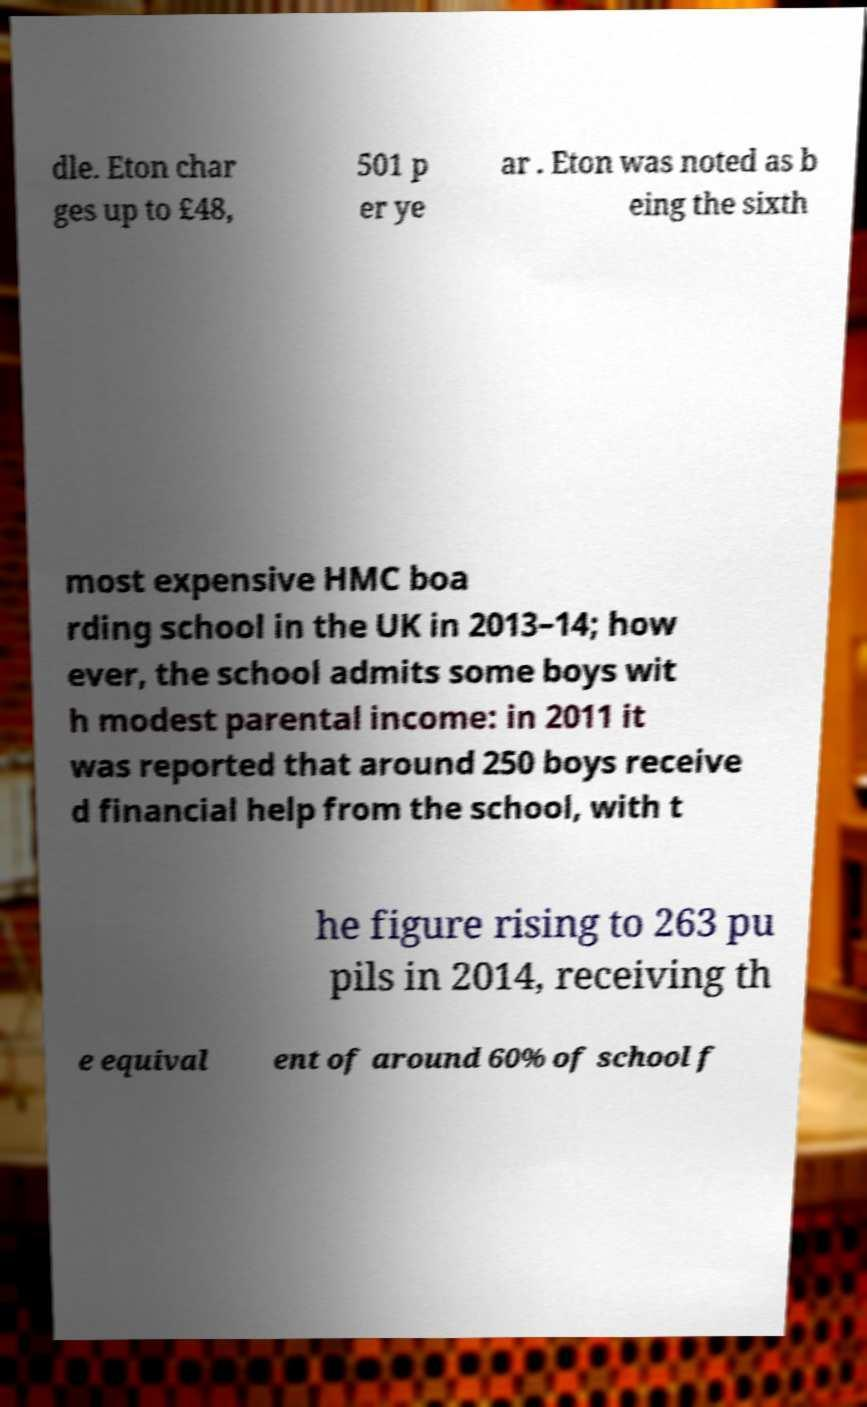For documentation purposes, I need the text within this image transcribed. Could you provide that? dle. Eton char ges up to £48, 501 p er ye ar . Eton was noted as b eing the sixth most expensive HMC boa rding school in the UK in 2013–14; how ever, the school admits some boys wit h modest parental income: in 2011 it was reported that around 250 boys receive d financial help from the school, with t he figure rising to 263 pu pils in 2014, receiving th e equival ent of around 60% of school f 